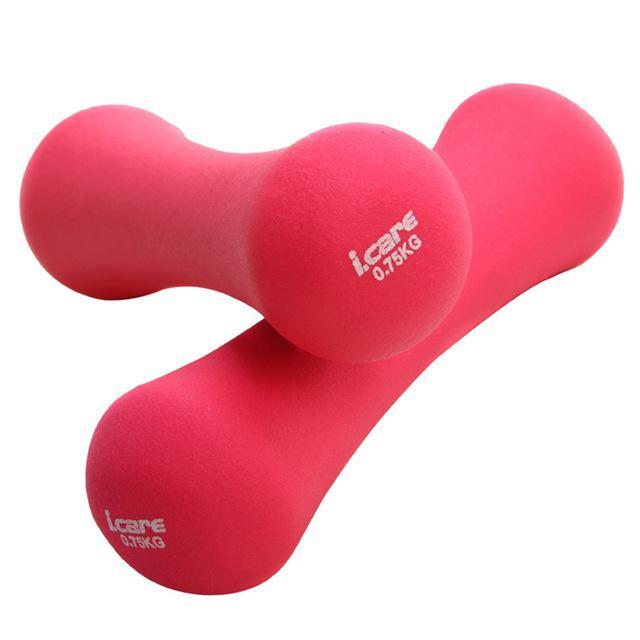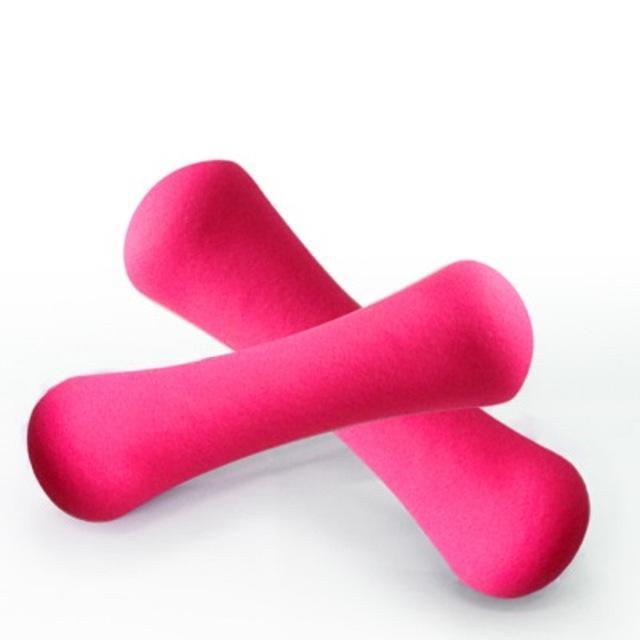The first image is the image on the left, the second image is the image on the right. Evaluate the accuracy of this statement regarding the images: "One image contains two each of three different colors of barbell-shaped weights.". Is it true? Answer yes or no. No. The first image is the image on the left, the second image is the image on the right. Examine the images to the left and right. Is the description "The left and right image contains the a total of eight weights." accurate? Answer yes or no. No. 